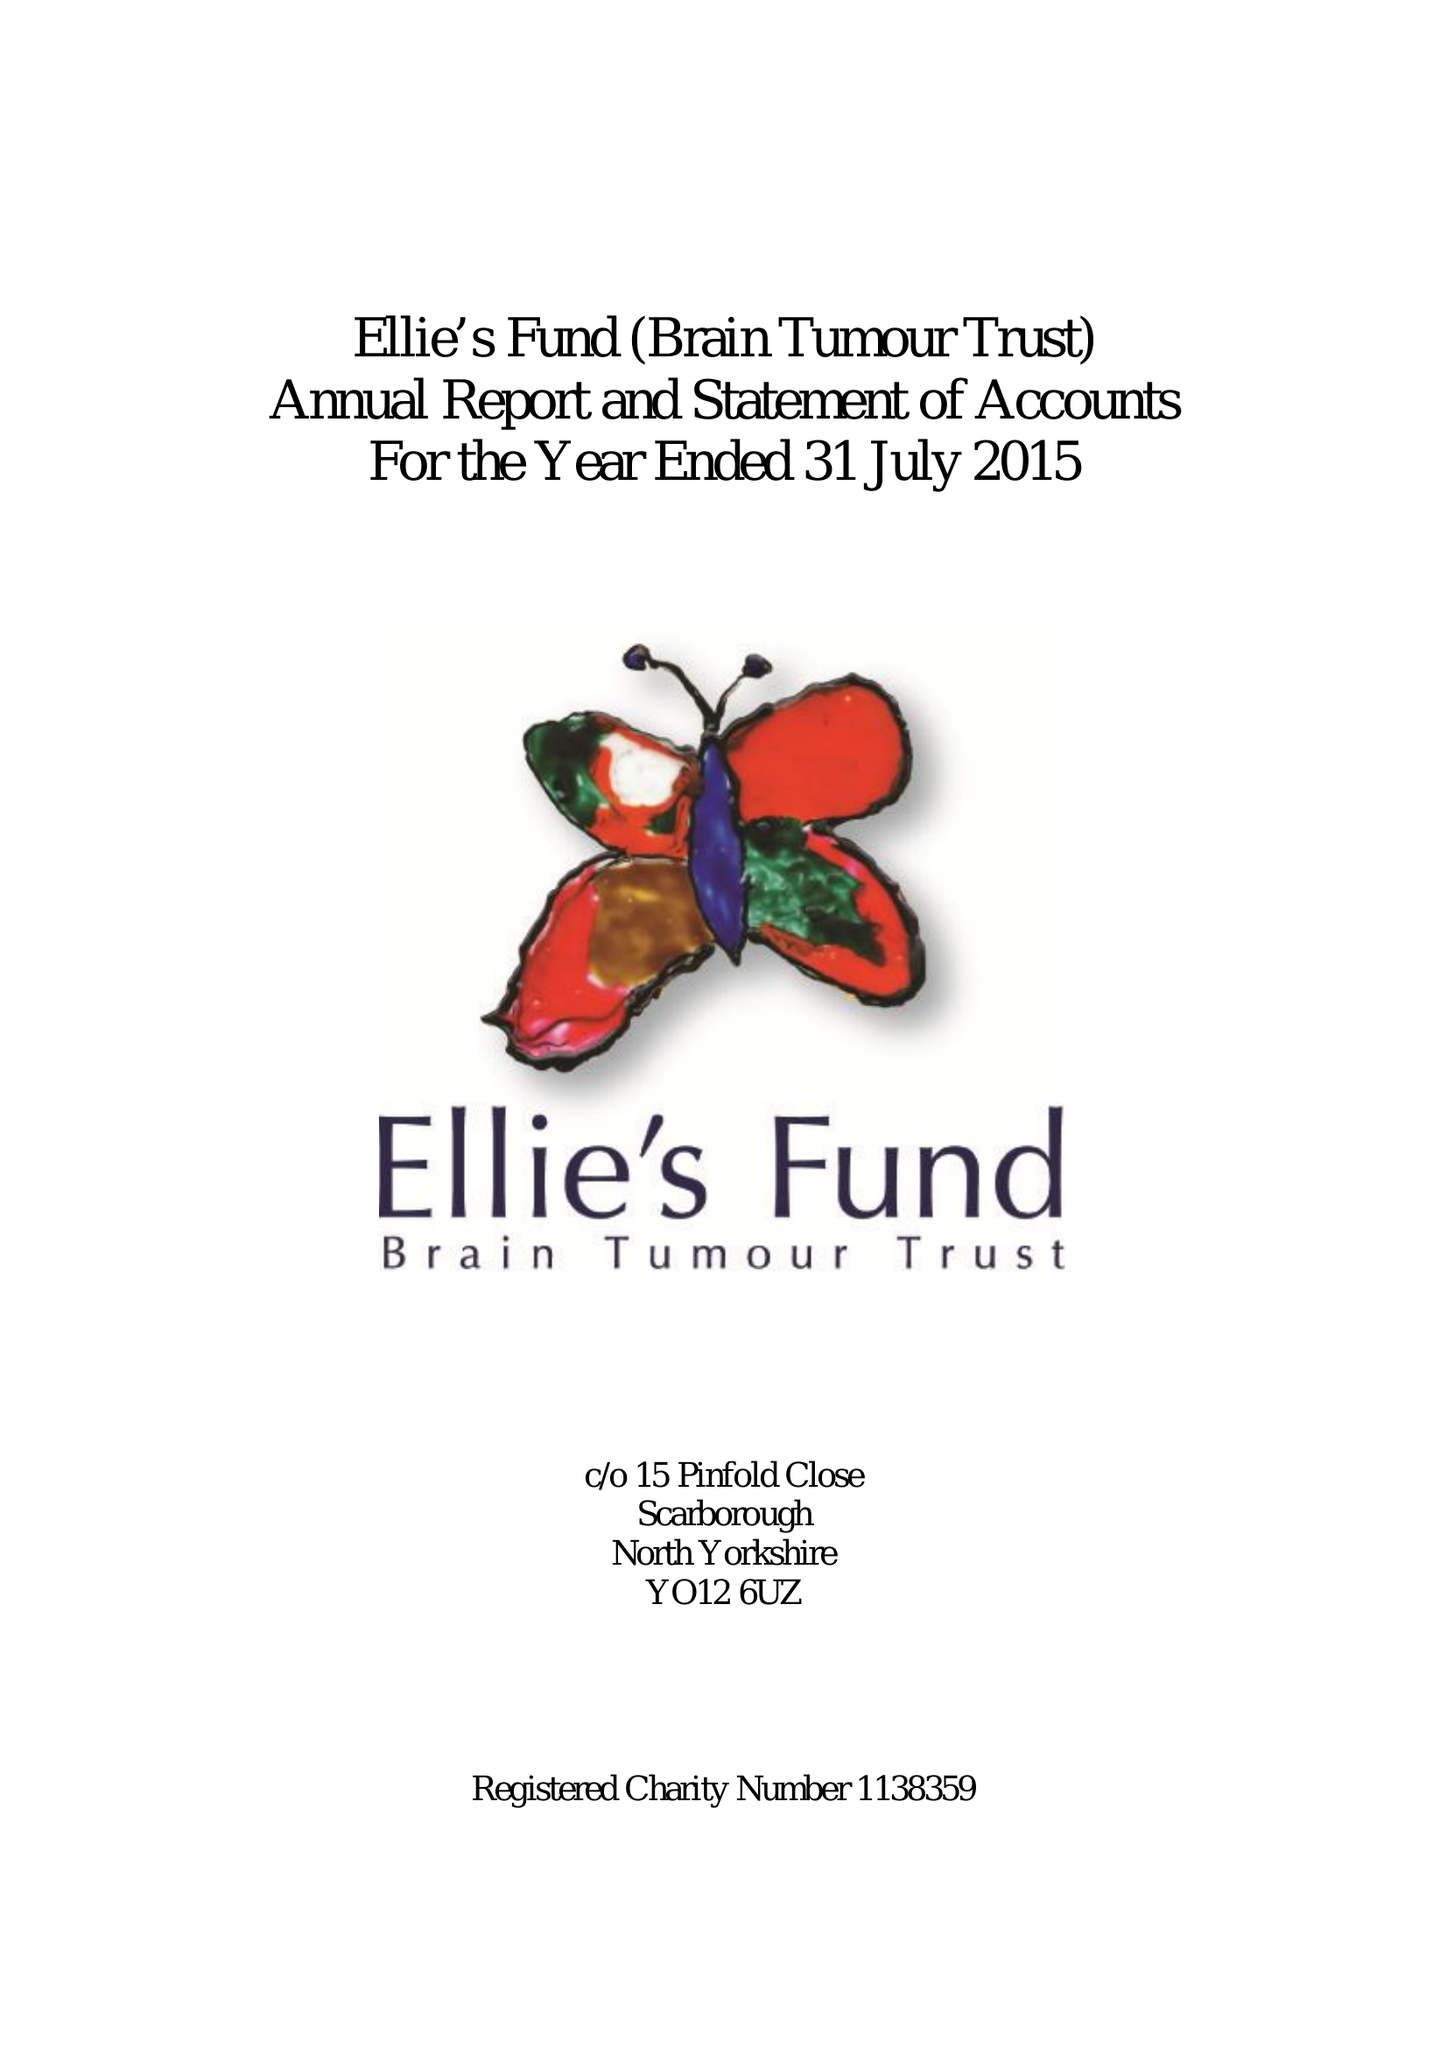What is the value for the charity_number?
Answer the question using a single word or phrase. 1138359 